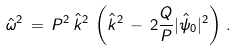Convert formula to latex. <formula><loc_0><loc_0><loc_500><loc_500>\hat { \omega } ^ { 2 } \, = \, P ^ { 2 } \, \hat { k } ^ { 2 } \, \left ( \hat { k } ^ { 2 } \, - \, 2 \frac { Q } { P } | \hat { \psi } _ { 0 } | ^ { 2 } \right ) \, .</formula> 